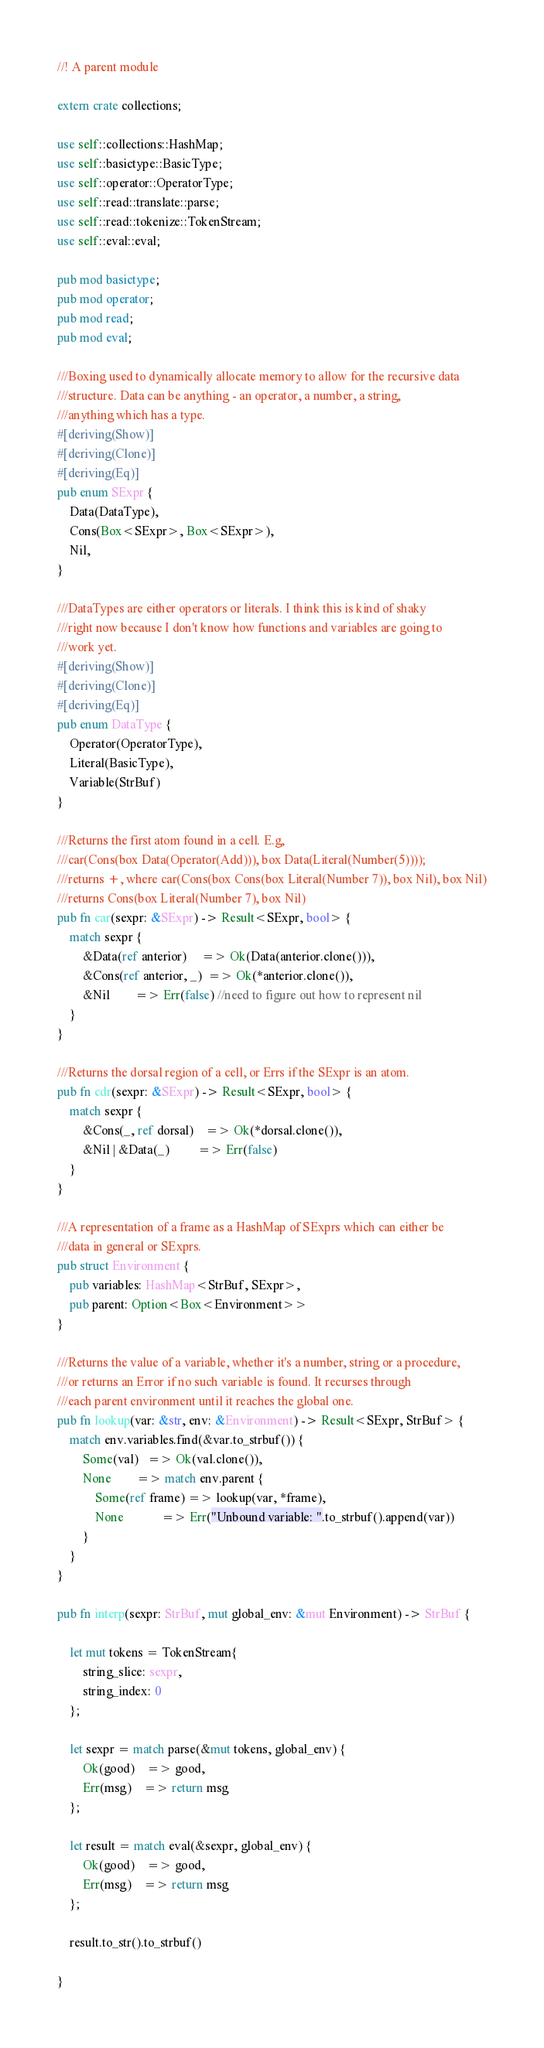<code> <loc_0><loc_0><loc_500><loc_500><_Rust_>//! A parent module

extern crate collections;

use self::collections::HashMap;
use self::basictype::BasicType;
use self::operator::OperatorType;
use self::read::translate::parse;
use self::read::tokenize::TokenStream;
use self::eval::eval;

pub mod basictype;
pub mod operator;
pub mod read;
pub mod eval;

///Boxing used to dynamically allocate memory to allow for the recursive data 
///structure. Data can be anything - an operator, a number, a string,
///anything which has a type.
#[deriving(Show)]
#[deriving(Clone)]
#[deriving(Eq)]
pub enum SExpr {
    Data(DataType),
    Cons(Box<SExpr>, Box<SExpr>),
    Nil,
}

///DataTypes are either operators or literals. I think this is kind of shaky
///right now because I don't know how functions and variables are going to
///work yet.
#[deriving(Show)]
#[deriving(Clone)]
#[deriving(Eq)]
pub enum DataType {
    Operator(OperatorType),
    Literal(BasicType),
    Variable(StrBuf)
}

///Returns the first atom found in a cell. E.g,
///car(Cons(box Data(Operator(Add))), box Data(Literal(Number(5))));
///returns +, where car(Cons(box Cons(box Literal(Number 7)), box Nil), box Nil)
///returns Cons(box Literal(Number 7), box Nil)
pub fn car(sexpr: &SExpr) -> Result<SExpr, bool> {
    match sexpr {
        &Data(ref anterior)     => Ok(Data(anterior.clone())),
        &Cons(ref anterior, _)  => Ok(*anterior.clone()),
        &Nil        => Err(false) //need to figure out how to represent nil
    }
}

///Returns the dorsal region of a cell, or Errs if the SExpr is an atom.
pub fn cdr(sexpr: &SExpr) -> Result<SExpr, bool> {
    match sexpr {
        &Cons(_, ref dorsal)    => Ok(*dorsal.clone()),
        &Nil | &Data(_)         => Err(false)
    }
}

///A representation of a frame as a HashMap of SExprs which can either be
///data in general or SExprs.
pub struct Environment {
    pub variables: HashMap<StrBuf, SExpr>,
    pub parent: Option<Box<Environment>>
}

///Returns the value of a variable, whether it's a number, string or a procedure,
///or returns an Error if no such variable is found. It recurses through
///each parent environment until it reaches the global one.
pub fn lookup(var: &str, env: &Environment) -> Result<SExpr, StrBuf> {
    match env.variables.find(&var.to_strbuf()) {
        Some(val)   => Ok(val.clone()),
        None        => match env.parent {
            Some(ref frame) => lookup(var, *frame),
            None            => Err("Unbound variable: ".to_strbuf().append(var))
        }
    }
}

pub fn interp(sexpr: StrBuf, mut global_env: &mut Environment) -> StrBuf {

    let mut tokens = TokenStream{
        string_slice: sexpr,
        string_index: 0
    };

    let sexpr = match parse(&mut tokens, global_env) {
        Ok(good)    => good,
        Err(msg)    => return msg
    };

    let result = match eval(&sexpr, global_env) {
        Ok(good)    => good,
        Err(msg)    => return msg
    };

    result.to_str().to_strbuf()

}
</code> 